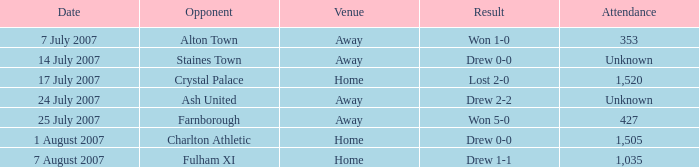What is the location of the staines town venue? Away. 